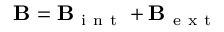<formula> <loc_0><loc_0><loc_500><loc_500>B = B _ { i n t } + B _ { e x t }</formula> 